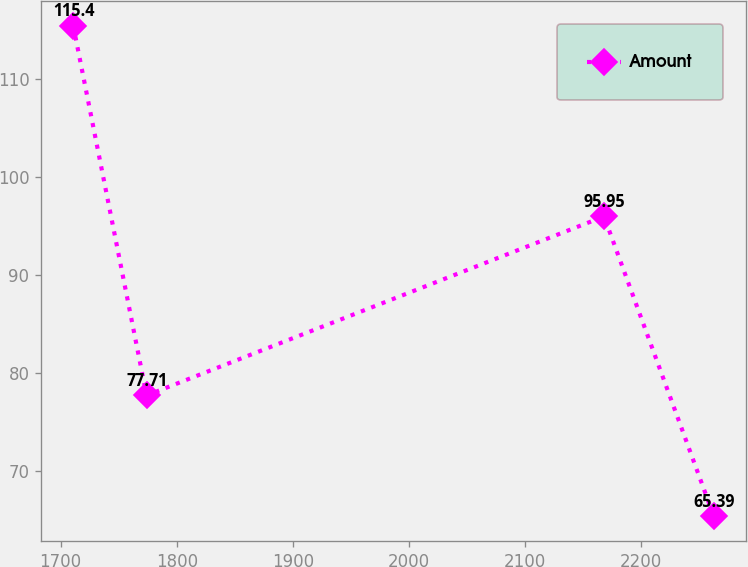Convert chart to OTSL. <chart><loc_0><loc_0><loc_500><loc_500><line_chart><ecel><fcel>Amount<nl><fcel>1710.87<fcel>115.4<nl><fcel>1774.07<fcel>77.71<nl><fcel>2167.89<fcel>95.95<nl><fcel>2262.47<fcel>65.39<nl></chart> 